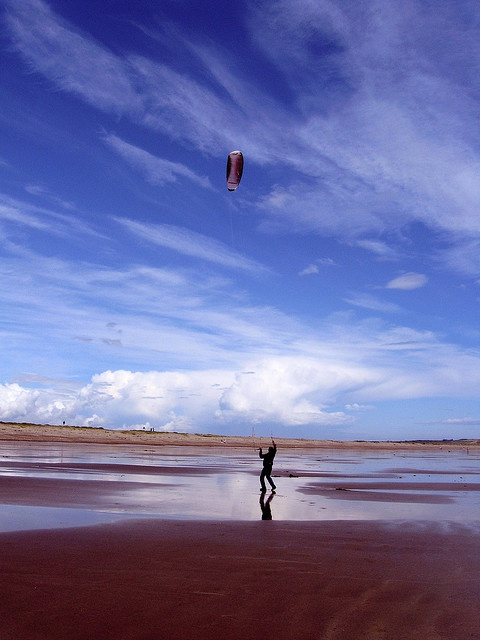Describe the objects in this image and their specific colors. I can see people in darkblue, black, gray, brown, and darkgray tones and kite in darkblue, black, and purple tones in this image. 